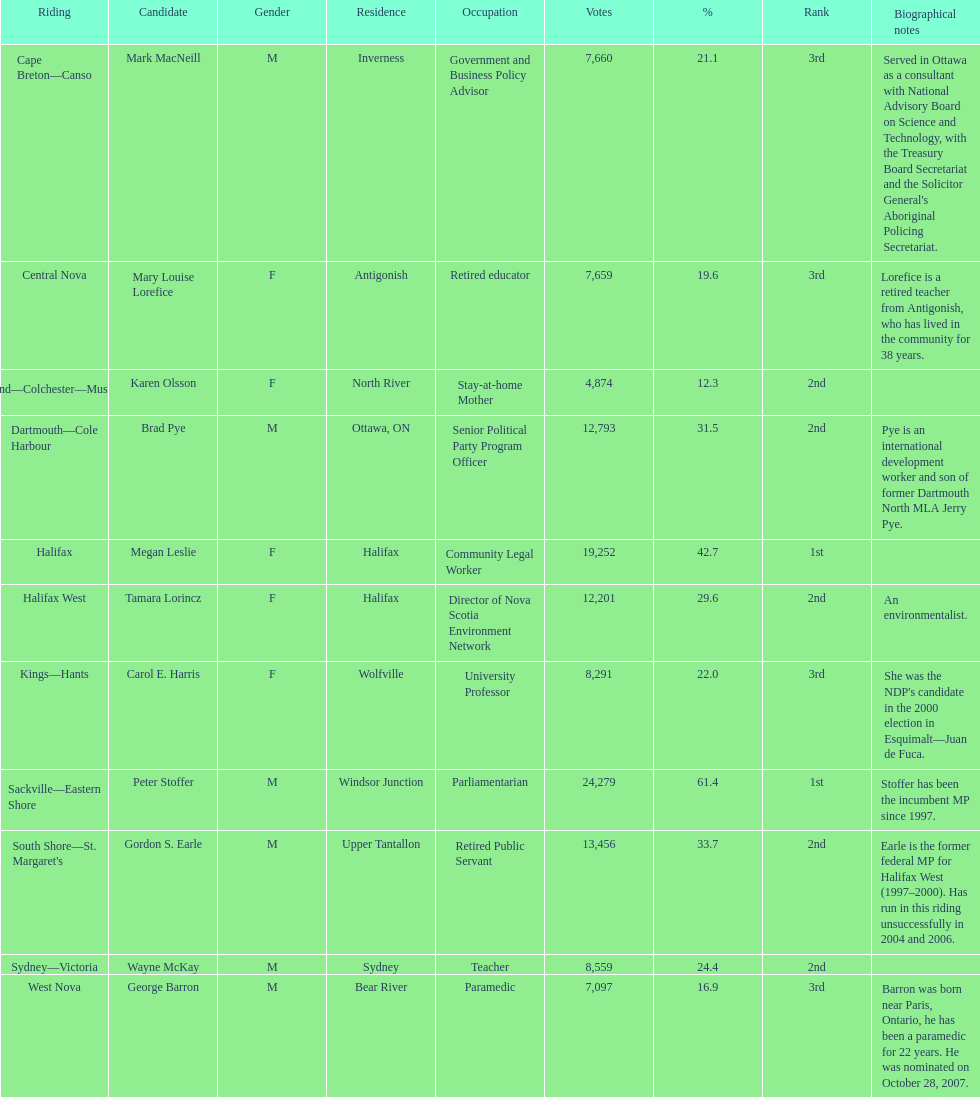In the 2008 canadian federal election, who were the new democratic party contenders? Mark MacNeill, Mary Louise Lorefice, Karen Olsson, Brad Pye, Megan Leslie, Tamara Lorincz, Carol E. Harris, Peter Stoffer, Gordon S. Earle, Wayne McKay, George Barron. Can you identify the female candidates among them? Mary Louise Lorefice, Karen Olsson, Megan Leslie, Tamara Lorincz, Carol E. Harris. Which candidate had a residence in halifax? Megan Leslie, Tamara Lorincz. Among the remaining two, who achieved the top rank? Megan Leslie. How many votes did she receive? 19,252. 